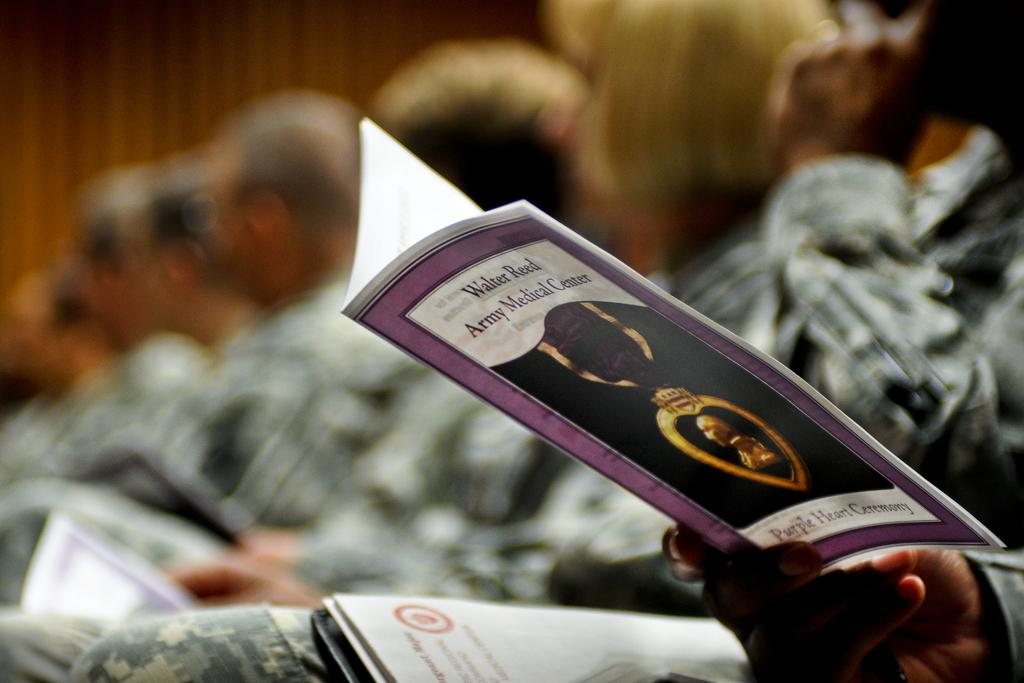<image>
Render a clear and concise summary of the photo. a book that has the word army on the cover 